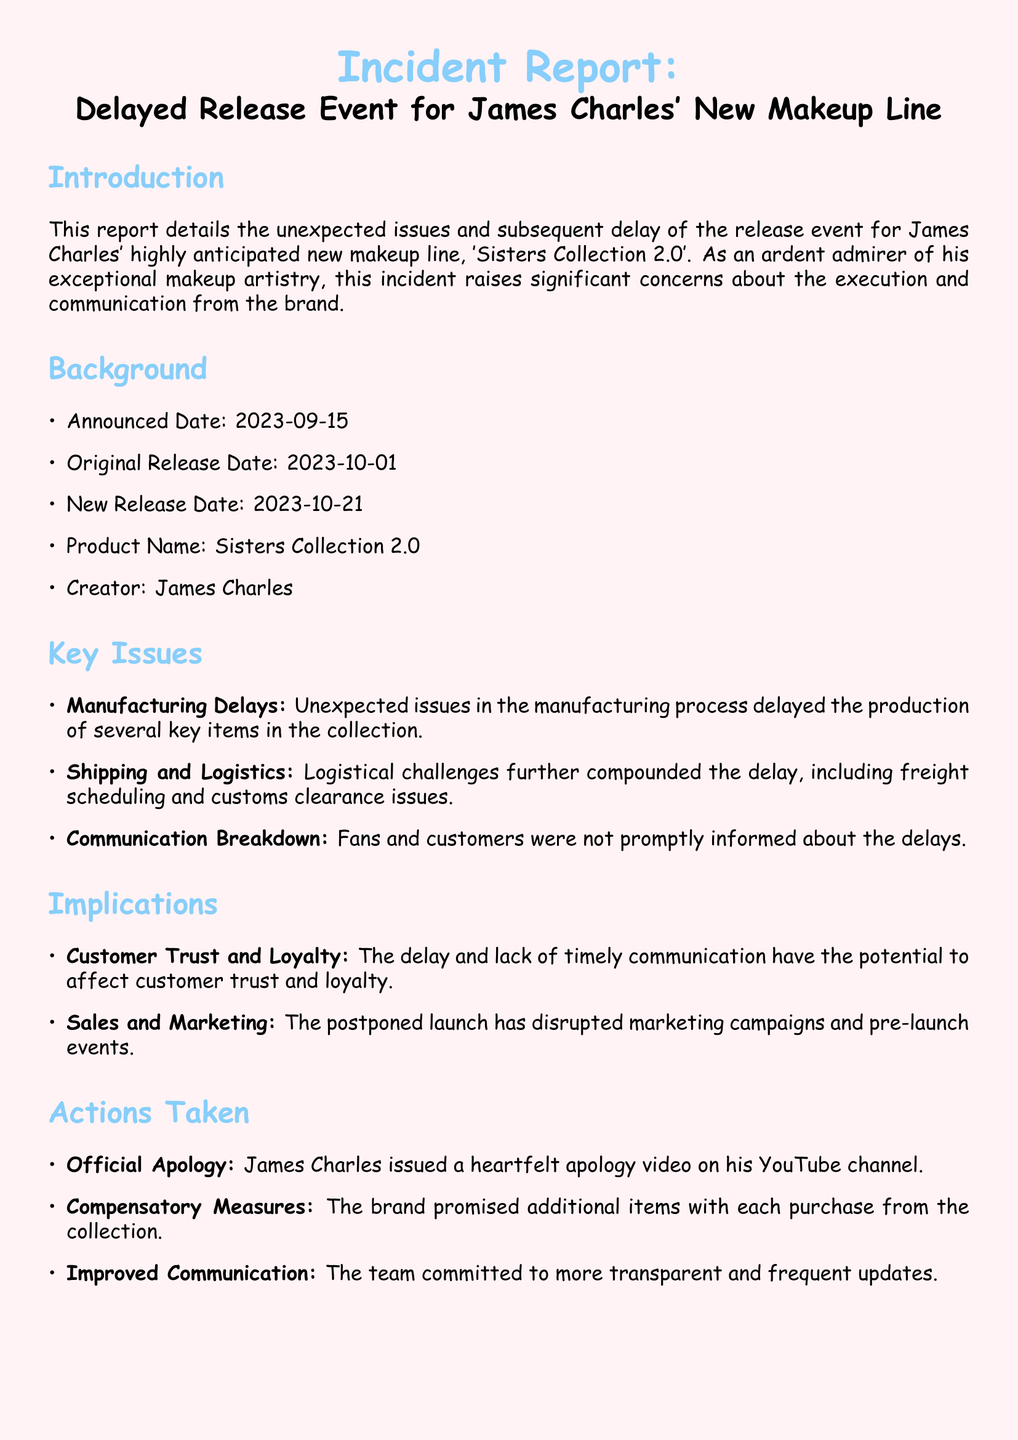What is the name of the new makeup line? The document states that the new makeup line is called 'Sisters Collection 2.0'.
Answer: 'Sisters Collection 2.0' When was the original release date? The original release date mentioned in the report is 2023-10-01.
Answer: 2023-10-01 What is the new release date? According to the report, the new release date is 2023-10-21.
Answer: 2023-10-21 What was the reason for the delays? The report lists manufacturing delays, shipping and logistics issues, and communication breakdowns as reasons for the delays.
Answer: Manufacturing delays What measures did James Charles take in response to the delays? The measures taken include issuing an official apology, offering additional items with each purchase, and committing to improved communication.
Answer: Official apology How has the delay affected customer trust? The document implies that the delay and poor communication could potentially harm customer trust and loyalty.
Answer: Harm customer trust Who created the 'Sisters Collection 2.0'? The report identifies James Charles as the creator of the collection.
Answer: James Charles What type of issues compounded the delay? The report mentions that logistical challenges were among the issues that compounded the delay.
Answer: Logistical challenges What commitment did the team make regarding communication? The document states that the team committed to more transparent and frequent updates.
Answer: More transparent and frequent updates 